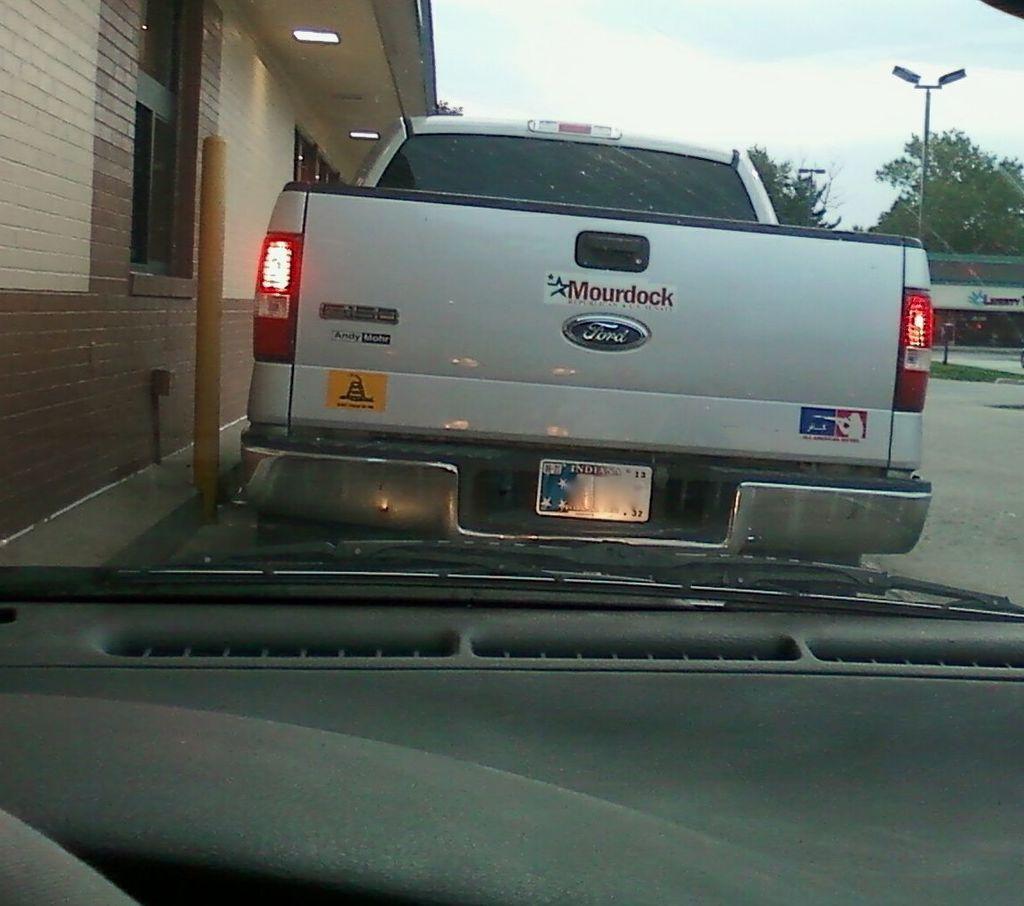What brand is the white truck?
Your answer should be compact. Ford. What state is on the license plate?
Your response must be concise. Indiana. 